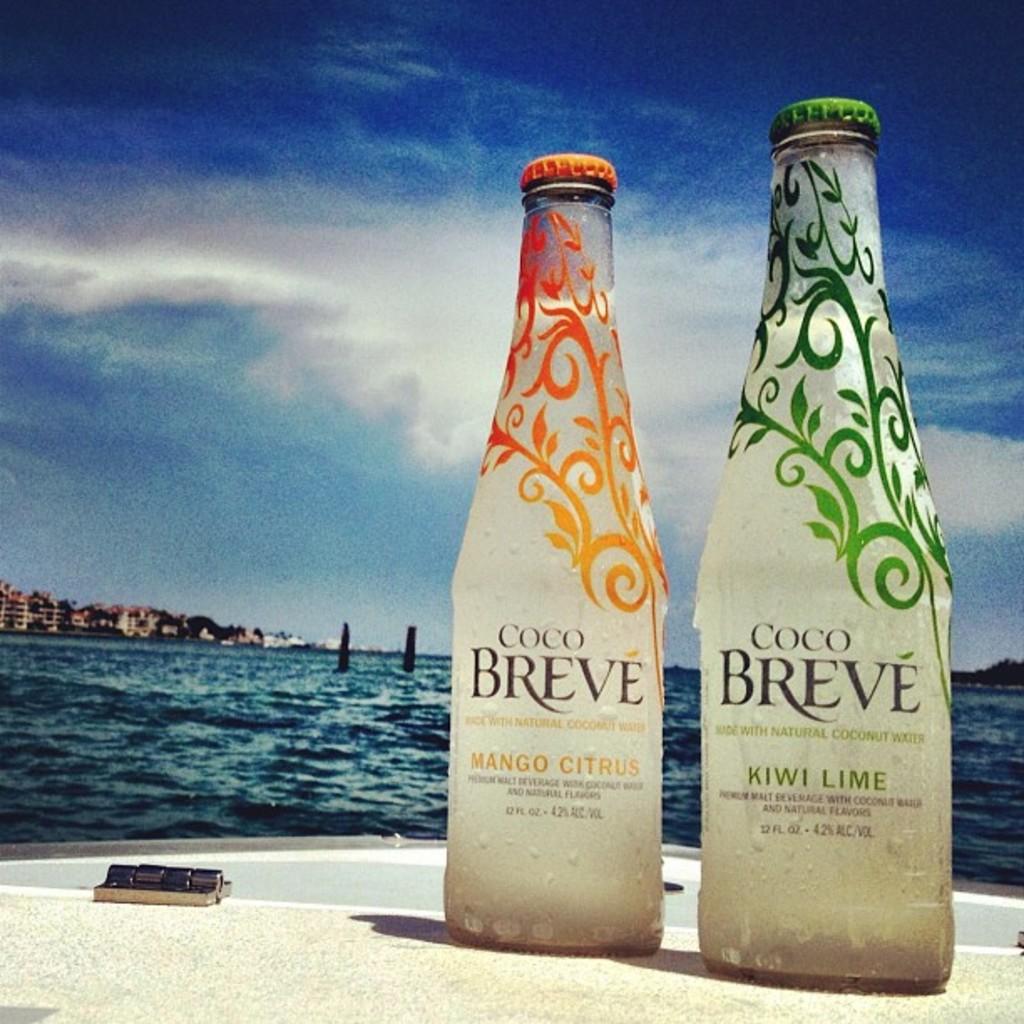What kind of lime is the coco breve?
Keep it short and to the point. Kiwi. What is the flavor of the orange bottle?
Your response must be concise. Mango citrus. 